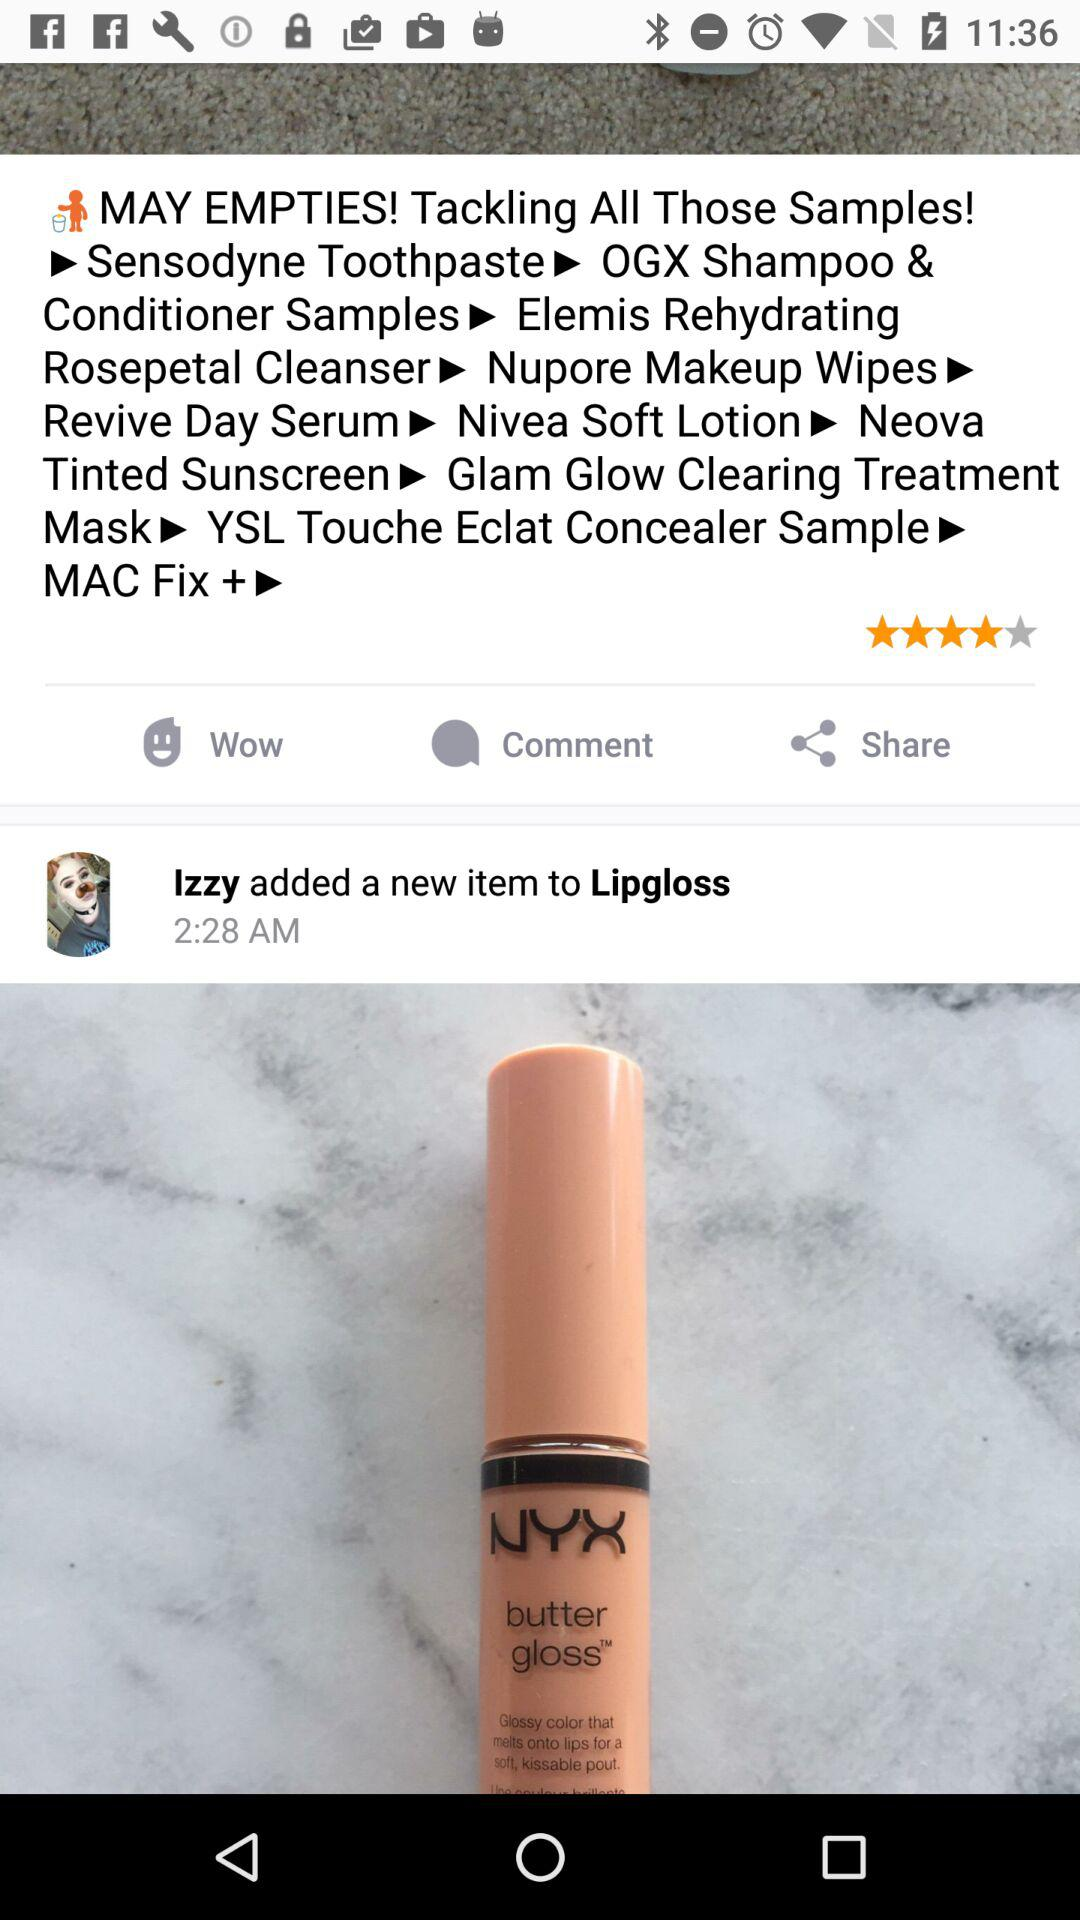What is the rating of the lipgloss? The rating is 4 stars. 